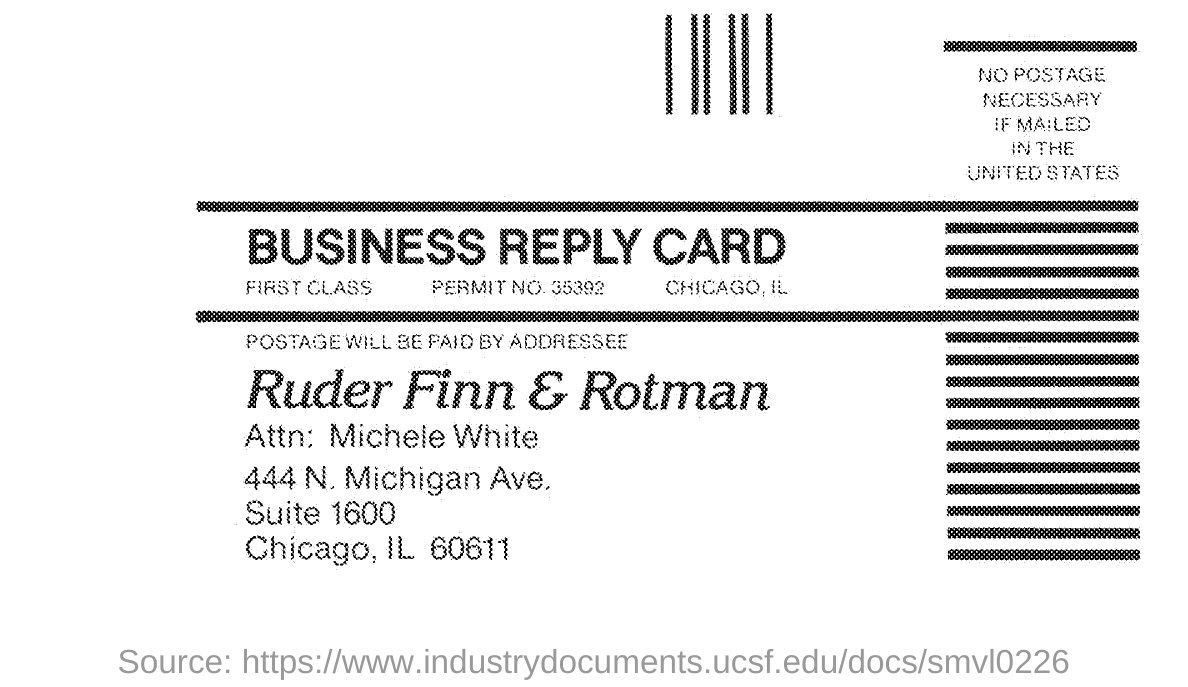What is the Permit No. mentioned in the Business Reply Card?
Make the answer very short. 35392. 